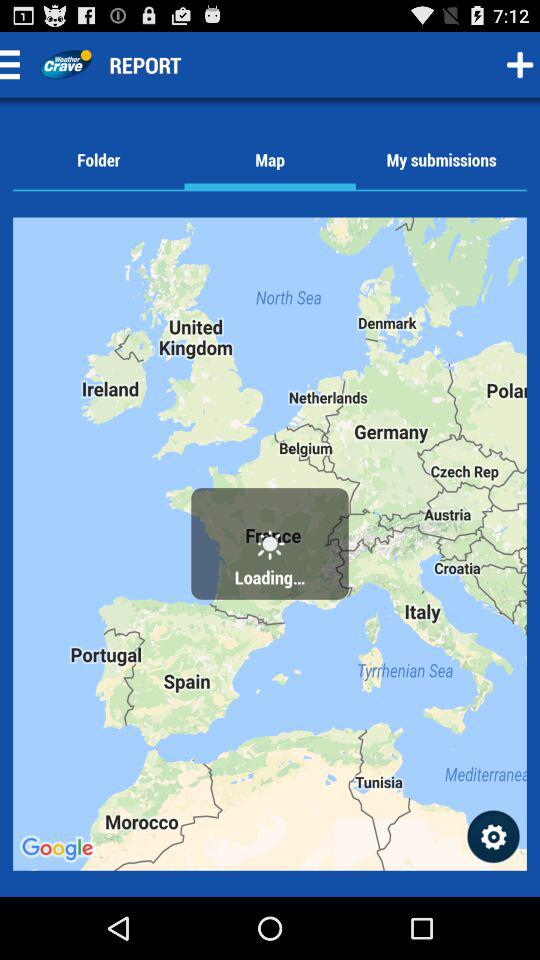When was the weather report last updated?
When the provided information is insufficient, respond with <no answer>. <no answer> 